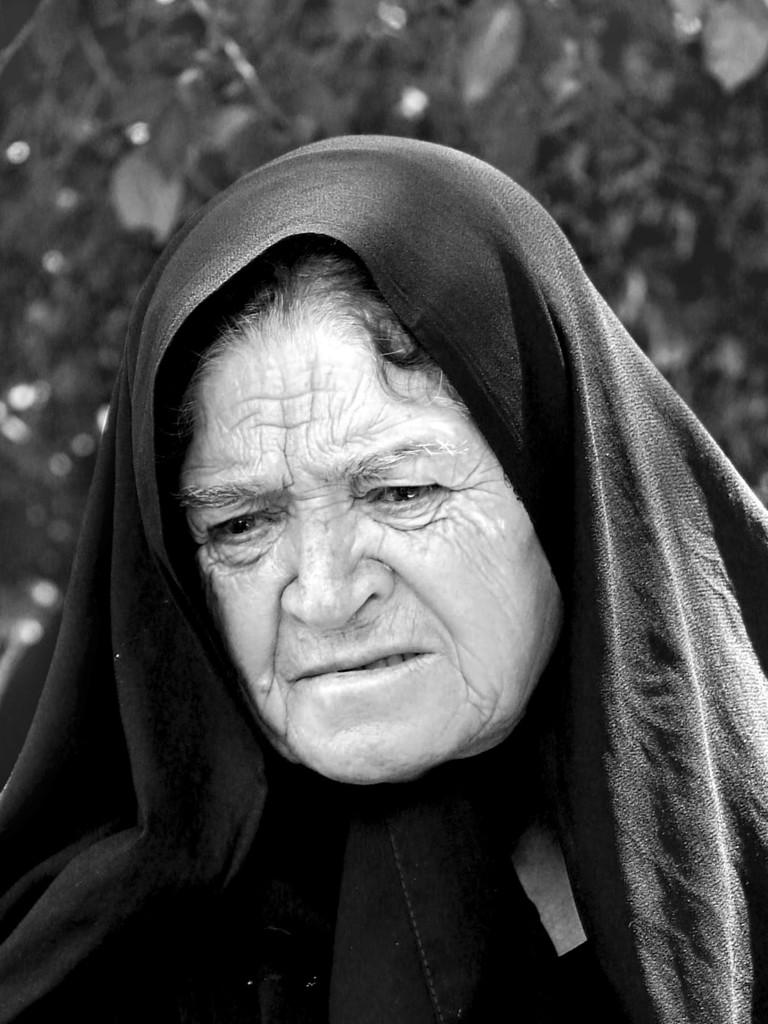Who is the main subject in the picture? There is an old woman in the picture. What is the old woman wearing on her head? The old woman is wearing a black cloth on her head. What can be seen in the background of the picture? There are trees visible in the background of the picture. How many grapes can be seen in the old woman's hand in the picture? There are no grapes visible in the old woman's hand in the picture. Can you describe the old woman's reaction to the kiss in the image? There is no kiss depicted in the image, so it is not possible to describe the old woman's reaction to it. 